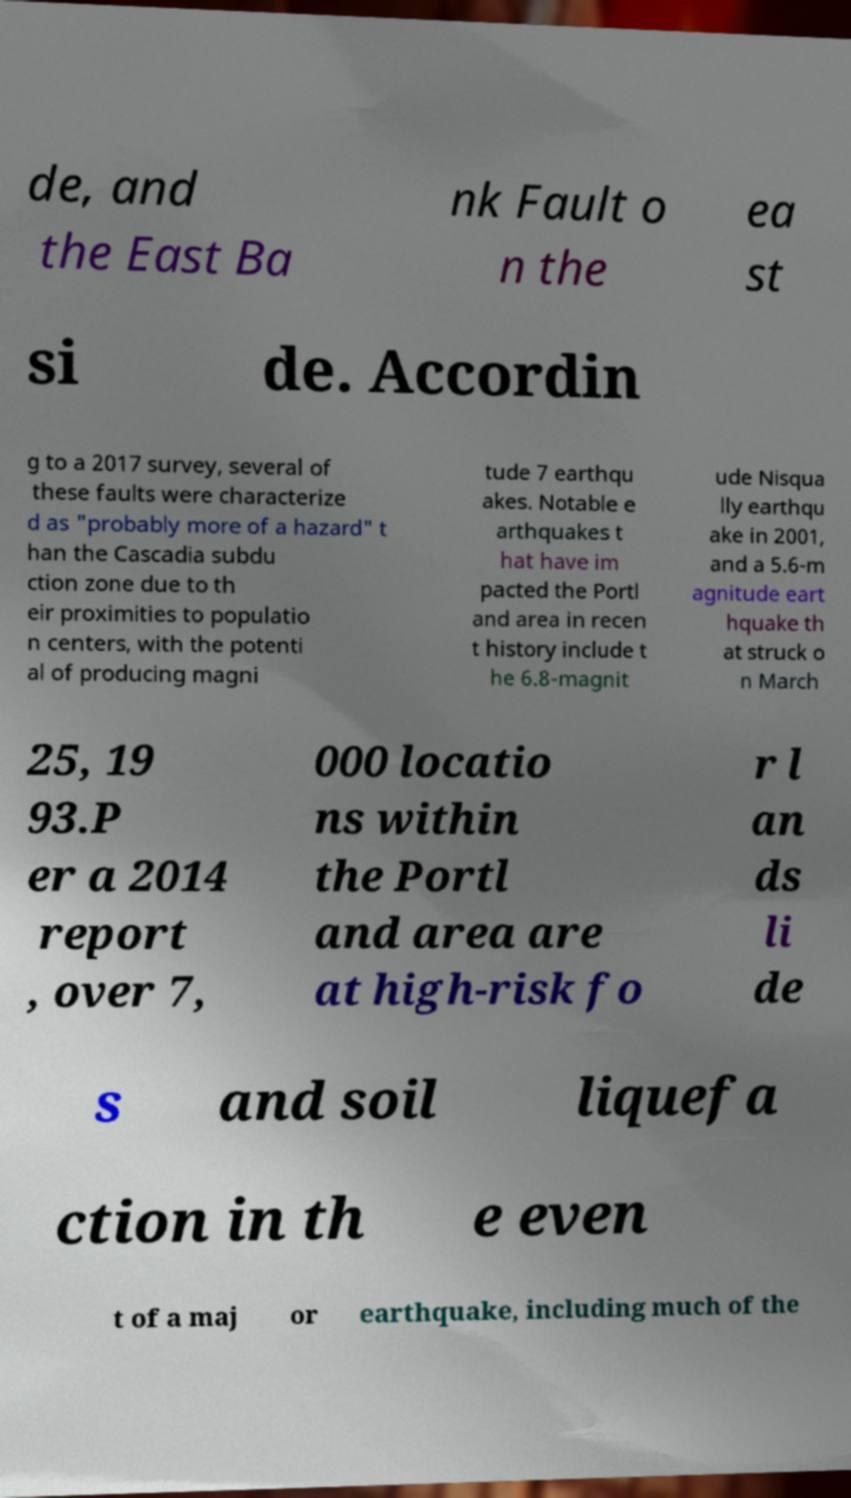Please identify and transcribe the text found in this image. de, and the East Ba nk Fault o n the ea st si de. Accordin g to a 2017 survey, several of these faults were characterize d as "probably more of a hazard" t han the Cascadia subdu ction zone due to th eir proximities to populatio n centers, with the potenti al of producing magni tude 7 earthqu akes. Notable e arthquakes t hat have im pacted the Portl and area in recen t history include t he 6.8-magnit ude Nisqua lly earthqu ake in 2001, and a 5.6-m agnitude eart hquake th at struck o n March 25, 19 93.P er a 2014 report , over 7, 000 locatio ns within the Portl and area are at high-risk fo r l an ds li de s and soil liquefa ction in th e even t of a maj or earthquake, including much of the 